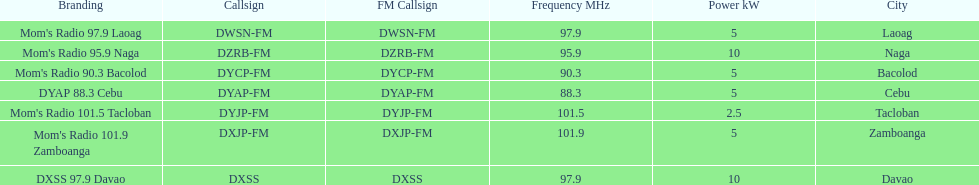What is the number of these stations broadcasting at a frequency of greater than 100 mhz? 2. 